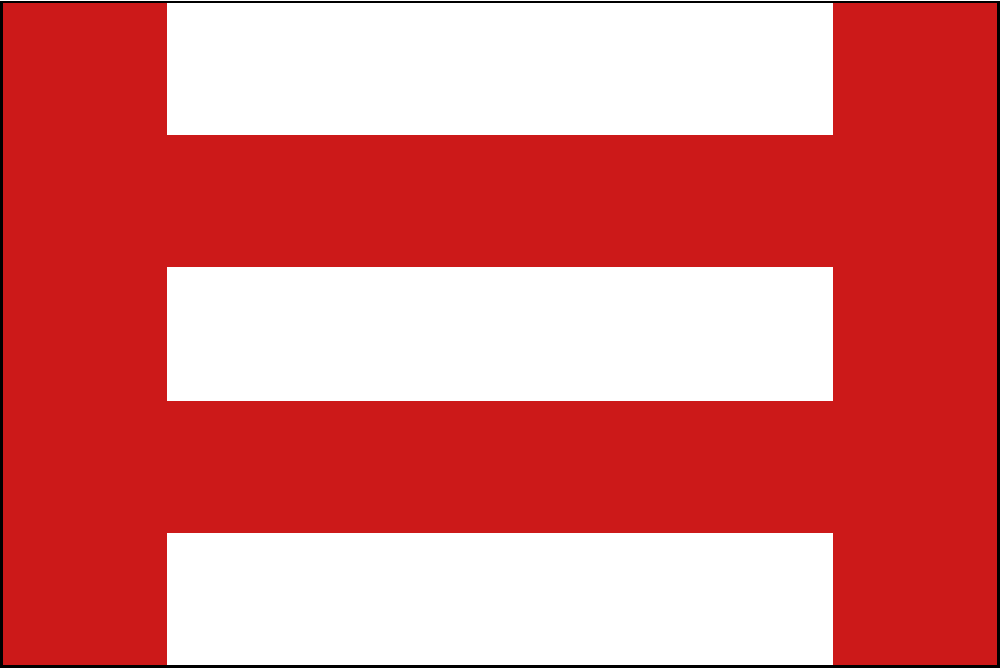Consider the flag shown above, which consists of a red background with three horizontal white stripes. What is the order of the rotational symmetry group of this flag, and what type of abstract group does it represent? To determine the order and type of the rotational symmetry group for this flag, we need to follow these steps:

1. Identify the symmetries:
   - The flag has 180° rotational symmetry (2-fold rotation).
   - It also has identity (no rotation, 360°).

2. Count the number of distinct rotations:
   - 0° (identity)
   - 180°
   
   There are 2 distinct rotations.

3. Determine the order of the group:
   The order of the group is equal to the number of distinct rotations, which is 2.

4. Identify the abstract group:
   A group of order 2 with elements that are their own inverses is isomorphic to the cyclic group $C_2$ or $\mathbb{Z}_2$.

5. Properties of $C_2$:
   - It has two elements: the identity element and one other element.
   - It is abelian (commutative).
   - It is cyclic, generated by the 180° rotation.
   - The group operation table is:
     $$\begin{array}{c|cc}
     * & e & r \\
     \hline
     e & e & r \\
     r & r & e
     \end{array}$$
   where $e$ is the identity and $r$ is the 180° rotation.

Therefore, the rotational symmetry group of this flag has order 2 and is isomorphic to the cyclic group $C_2$.
Answer: Order 2, cyclic group $C_2$ 